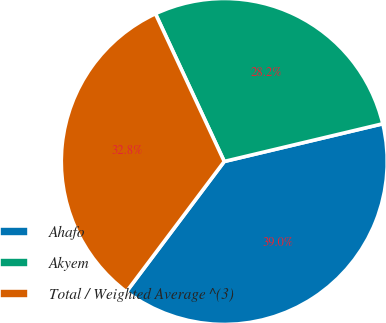<chart> <loc_0><loc_0><loc_500><loc_500><pie_chart><fcel>Ahafo<fcel>Akyem<fcel>Total / Weighted Average ^(3)<nl><fcel>38.97%<fcel>28.22%<fcel>32.81%<nl></chart> 